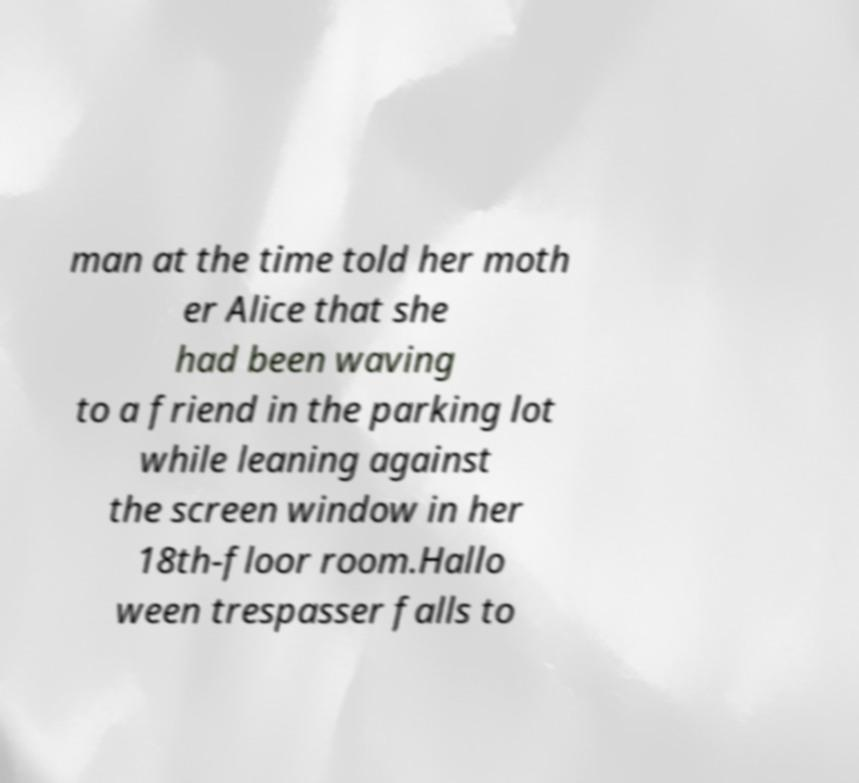Can you read and provide the text displayed in the image?This photo seems to have some interesting text. Can you extract and type it out for me? man at the time told her moth er Alice that she had been waving to a friend in the parking lot while leaning against the screen window in her 18th-floor room.Hallo ween trespasser falls to 